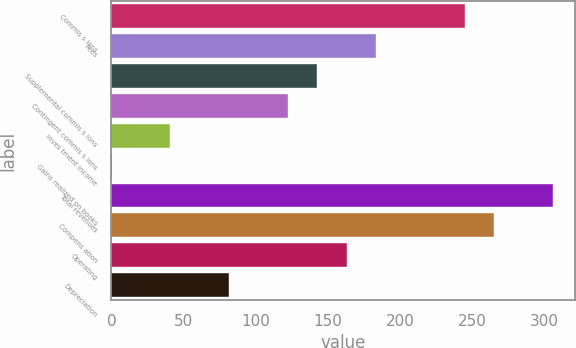Convert chart. <chart><loc_0><loc_0><loc_500><loc_500><bar_chart><fcel>Commis s ions<fcel>Fees<fcel>Supplemental commis s ions<fcel>Contingent commis s ions<fcel>Inves tment income<fcel>Gains realized on books<fcel>Total revenues<fcel>Compens ation<fcel>Operating<fcel>Depreciation<nl><fcel>244.66<fcel>183.52<fcel>142.76<fcel>122.38<fcel>40.86<fcel>0.1<fcel>305.8<fcel>265.04<fcel>163.14<fcel>81.62<nl></chart> 